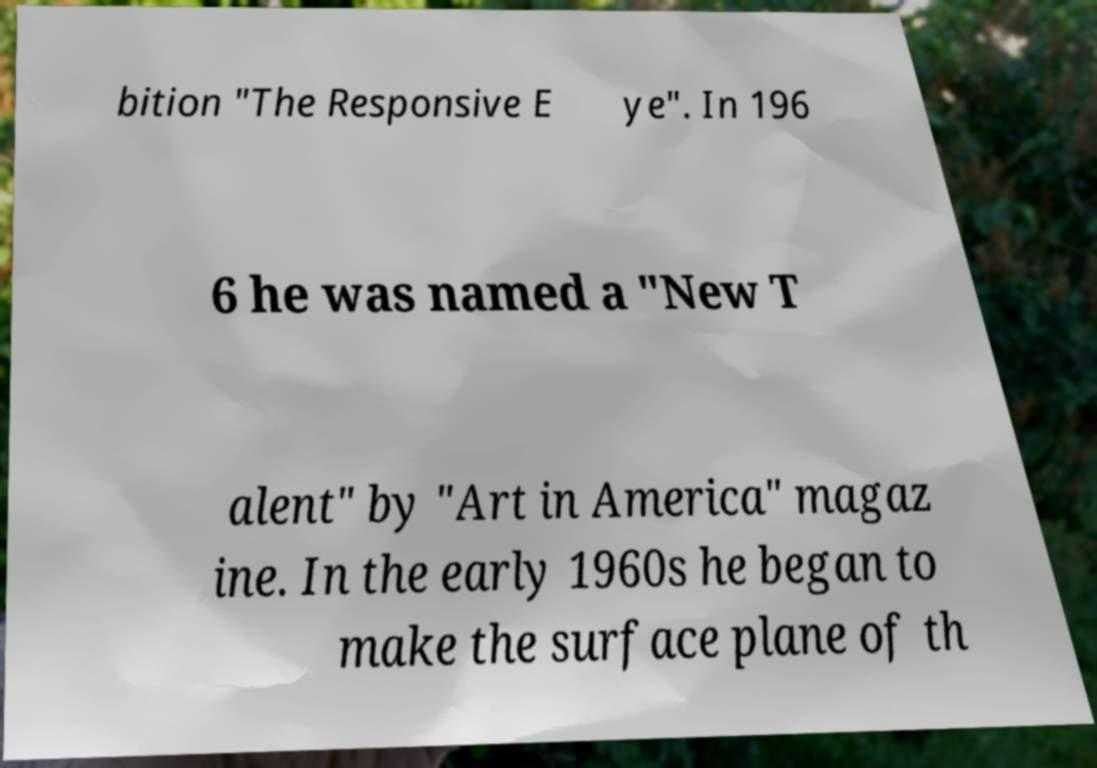There's text embedded in this image that I need extracted. Can you transcribe it verbatim? bition "The Responsive E ye". In 196 6 he was named a "New T alent" by "Art in America" magaz ine. In the early 1960s he began to make the surface plane of th 